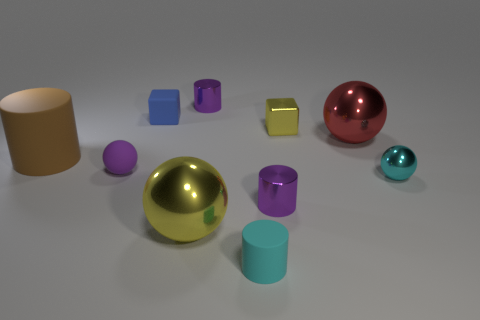Subtract all rubber balls. How many balls are left? 3 Subtract all gray spheres. How many purple cylinders are left? 2 Subtract all purple spheres. How many spheres are left? 3 Subtract 3 balls. How many balls are left? 1 Subtract all gray cylinders. Subtract all red balls. How many cylinders are left? 4 Subtract all cylinders. How many objects are left? 6 Subtract all small red cylinders. Subtract all cylinders. How many objects are left? 6 Add 1 tiny purple balls. How many tiny purple balls are left? 2 Add 7 tiny cyan metallic blocks. How many tiny cyan metallic blocks exist? 7 Subtract 1 cyan cylinders. How many objects are left? 9 